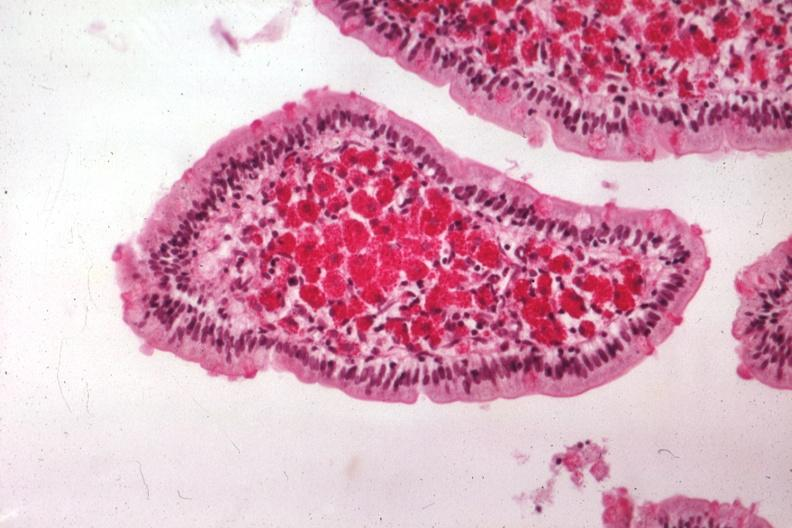s gastrointestinal present?
Answer the question using a single word or phrase. Yes 